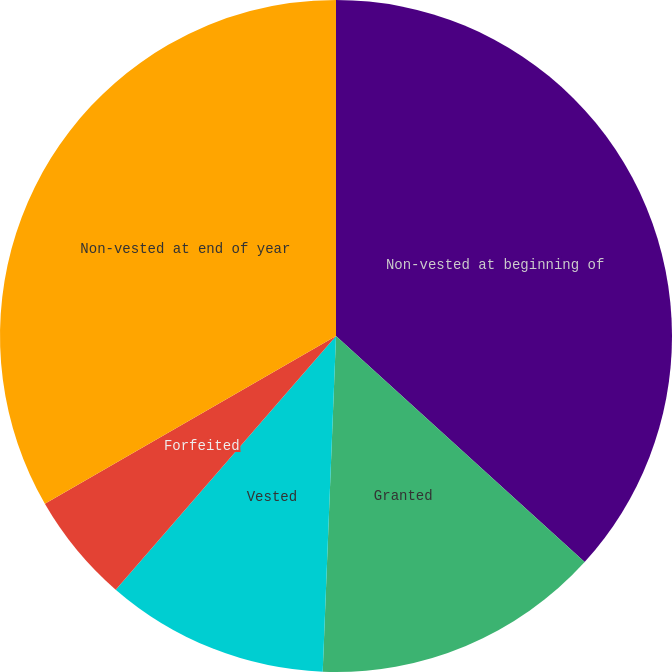Convert chart to OTSL. <chart><loc_0><loc_0><loc_500><loc_500><pie_chart><fcel>Non-vested at beginning of<fcel>Granted<fcel>Vested<fcel>Forfeited<fcel>Non-vested at end of year<nl><fcel>36.74%<fcel>13.89%<fcel>10.75%<fcel>5.3%<fcel>33.32%<nl></chart> 